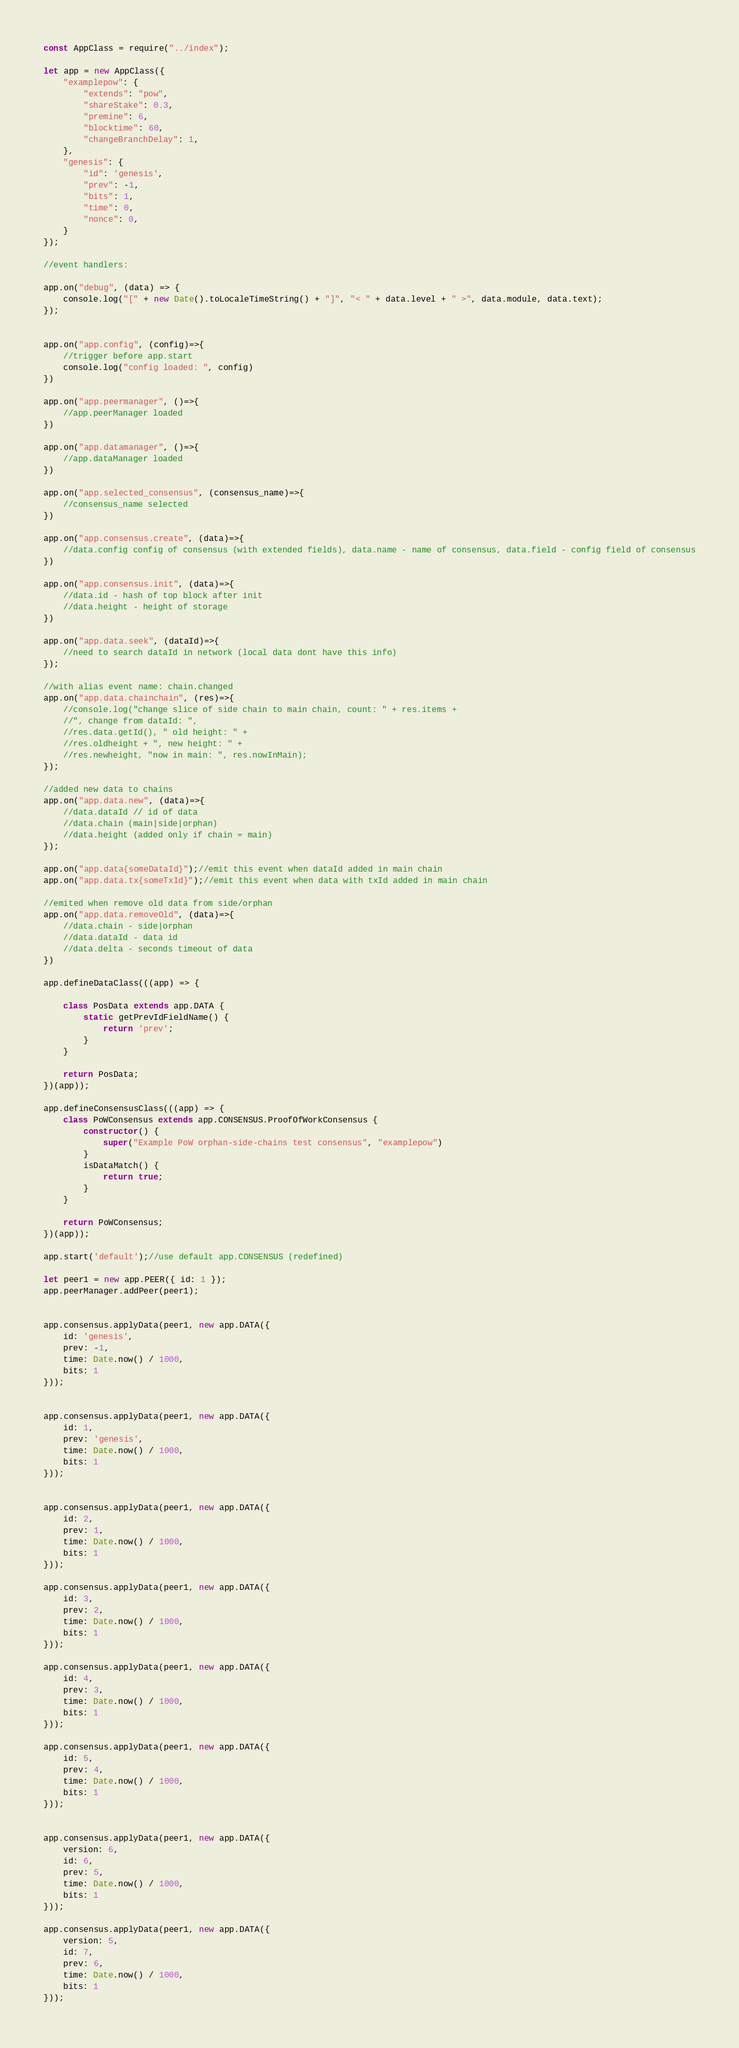Convert code to text. <code><loc_0><loc_0><loc_500><loc_500><_JavaScript_>const AppClass = require("../index");

let app = new AppClass({
    "examplepow": {
        "extends": "pow",
        "shareStake": 0.3,
        "premine": 6,
        "blocktime": 60,
        "changeBranchDelay": 1,
    },
    "genesis": {
        "id": 'genesis',
        "prev": -1,
        "bits": 1,
        "time": 0,
        "nonce": 0,
    }
});

//event handlers:

app.on("debug", (data) => {
    console.log("[" + new Date().toLocaleTimeString() + "]", "< " + data.level + " >", data.module, data.text);
});


app.on("app.config", (config)=>{
    //trigger before app.start
    console.log("config loaded: ", config)
})

app.on("app.peermanager", ()=>{
    //app.peerManager loaded
})

app.on("app.datamanager", ()=>{
    //app.dataManager loaded
})

app.on("app.selected_consensus", (consensus_name)=>{
    //consensus_name selected
})

app.on("app.consensus.create", (data)=>{
    //data.config config of consensus (with extended fields), data.name - name of consensus, data.field - config field of consensus
})

app.on("app.consensus.init", (data)=>{
    //data.id - hash of top block after init
    //data.height - height of storage
})

app.on("app.data.seek", (dataId)=>{
    //need to search dataId in network (local data dont have this info)
});

//with alias event name: chain.changed 
app.on("app.data.chainchain", (res)=>{
    //console.log("change slice of side chain to main chain, count: " + res.items + 
    //", change from dataId: ", 
    //res.data.getId(), " old height: " + 
    //res.oldheight + ", new height: " + 
    //res.newheight, "now in main: ", res.nowInMain);
});

//added new data to chains
app.on("app.data.new", (data)=>{
    //data.dataId // id of data
    //data.chain (main|side|orphan)
    //data.height (added only if chain = main)
});

app.on("app.data{someDataId}");//emit this event when dataId added in main chain
app.on("app.data.tx{someTxId}");//emit this event when data with txId added in main chain

//emited when remove old data from side/orphan 
app.on("app.data.removeOld", (data)=>{
    //data.chain - side|orphan
    //data.dataId - data id
    //data.delta - seconds timeout of data
})

app.defineDataClass(((app) => {

    class PosData extends app.DATA {
        static getPrevIdFieldName() {
            return 'prev';
        }
    }

    return PosData;
})(app));

app.defineConsensusClass(((app) => {
    class PoWConsensus extends app.CONSENSUS.ProofOfWorkConsensus {
        constructor() {
            super("Example PoW orphan-side-chains test consensus", "examplepow")
        }
        isDataMatch() {
            return true;
        }
    }

    return PoWConsensus;
})(app));

app.start('default');//use default app.CONSENSUS (redefined)

let peer1 = new app.PEER({ id: 1 });
app.peerManager.addPeer(peer1);


app.consensus.applyData(peer1, new app.DATA({
    id: 'genesis',
    prev: -1,
    time: Date.now() / 1000,
    bits: 1
}));


app.consensus.applyData(peer1, new app.DATA({
    id: 1,
    prev: 'genesis',
    time: Date.now() / 1000,
    bits: 1
}));


app.consensus.applyData(peer1, new app.DATA({
    id: 2,
    prev: 1,
    time: Date.now() / 1000,
    bits: 1
}));

app.consensus.applyData(peer1, new app.DATA({
    id: 3,
    prev: 2,
    time: Date.now() / 1000,
    bits: 1
}));

app.consensus.applyData(peer1, new app.DATA({
    id: 4,
    prev: 3,
    time: Date.now() / 1000,
    bits: 1
}));

app.consensus.applyData(peer1, new app.DATA({
    id: 5,
    prev: 4,
    time: Date.now() / 1000,
    bits: 1
}));


app.consensus.applyData(peer1, new app.DATA({
    version: 6,
    id: 6,
    prev: 5,
    time: Date.now() / 1000,
    bits: 1
}));

app.consensus.applyData(peer1, new app.DATA({
    version: 5,
    id: 7,
    prev: 6,
    time: Date.now() / 1000,
    bits: 1
}));</code> 